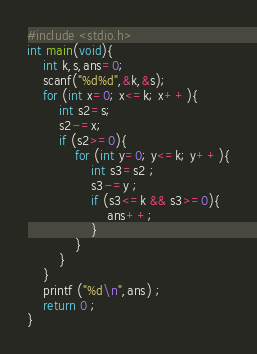<code> <loc_0><loc_0><loc_500><loc_500><_C_>#include <stdio.h>
int main(void){
    int k,s,ans=0;
    scanf("%d%d",&k,&s);
    for (int x=0; x<=k; x++){
        int s2=s;
        s2-=x;
        if (s2>=0){
            for (int y=0; y<=k; y++){
                int s3=s2 ;
                s3-=y ;
                if (s3<=k && s3>=0){
                    ans++;
                }
            }
        }
    }
    printf ("%d\n",ans) ;
	return 0 ;
}</code> 